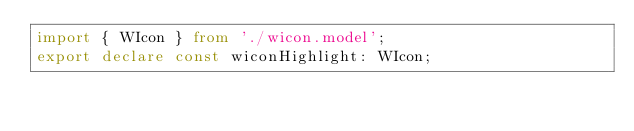Convert code to text. <code><loc_0><loc_0><loc_500><loc_500><_TypeScript_>import { WIcon } from './wicon.model';
export declare const wiconHighlight: WIcon;
</code> 